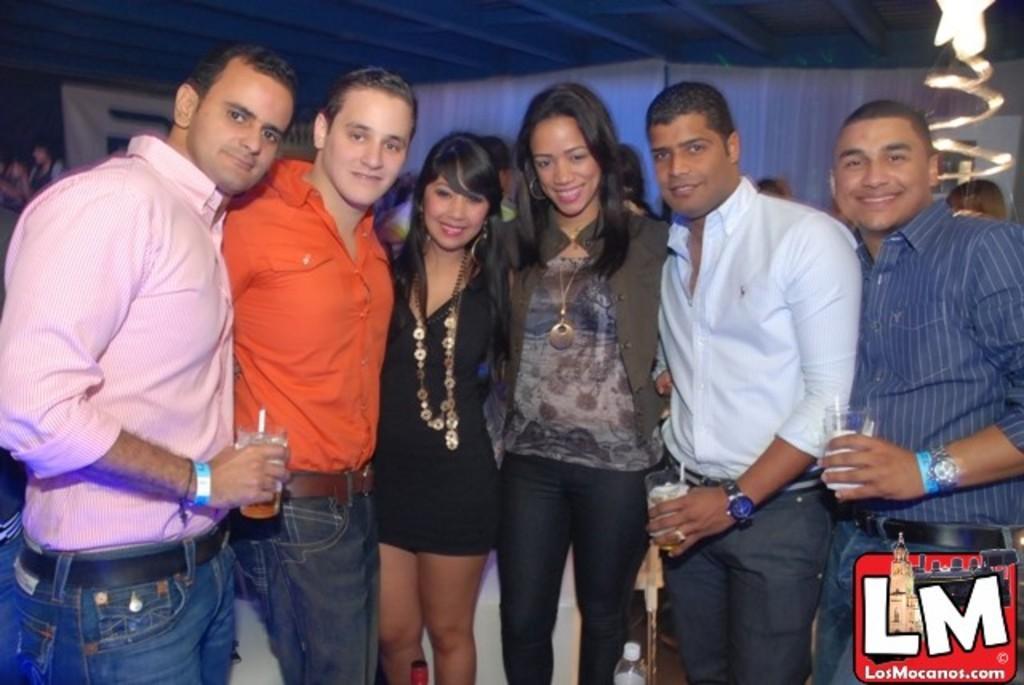In one or two sentences, can you explain what this image depicts? In this image, we can see a group of people are standing side by side and watching. Here we can see three men are holding glasses with straw. Background we can see people, curtains and banner. On the right side bottom corner, there is a logo in the image. 